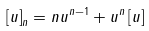<formula> <loc_0><loc_0><loc_500><loc_500>\left [ u \right ] _ { n } = n u ^ { n - 1 } + u ^ { n } \left [ u \right ]</formula> 